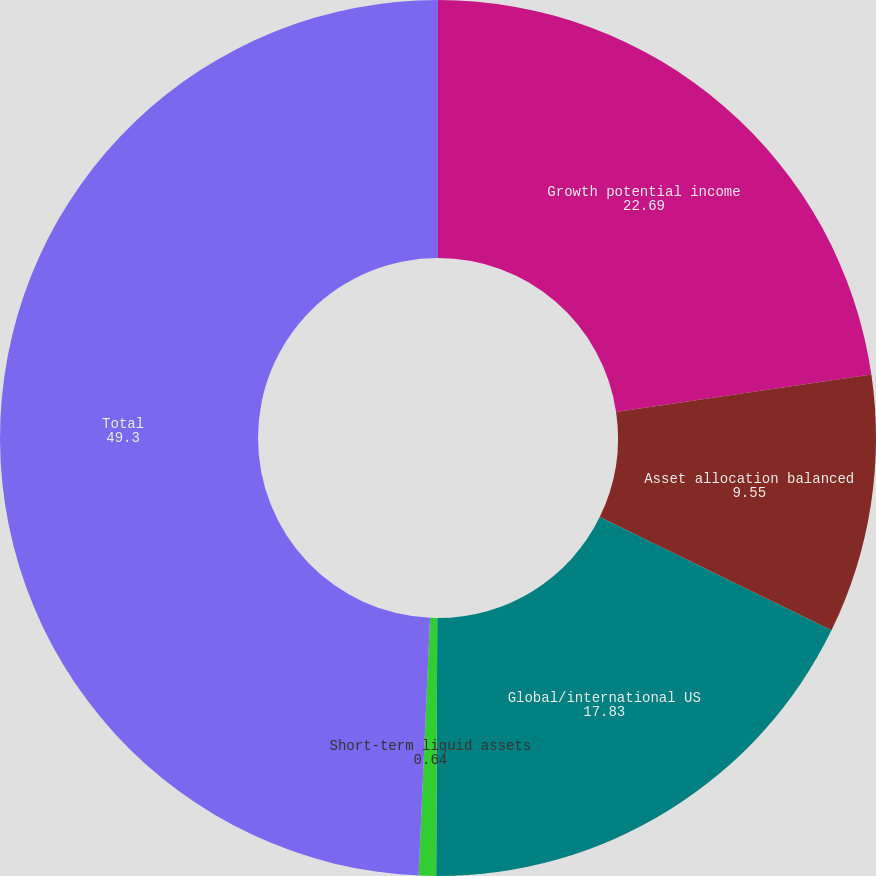<chart> <loc_0><loc_0><loc_500><loc_500><pie_chart><fcel>Growth potential income<fcel>Asset allocation balanced<fcel>Global/international US<fcel>Short-term liquid assets<fcel>Total<nl><fcel>22.69%<fcel>9.55%<fcel>17.83%<fcel>0.64%<fcel>49.3%<nl></chart> 